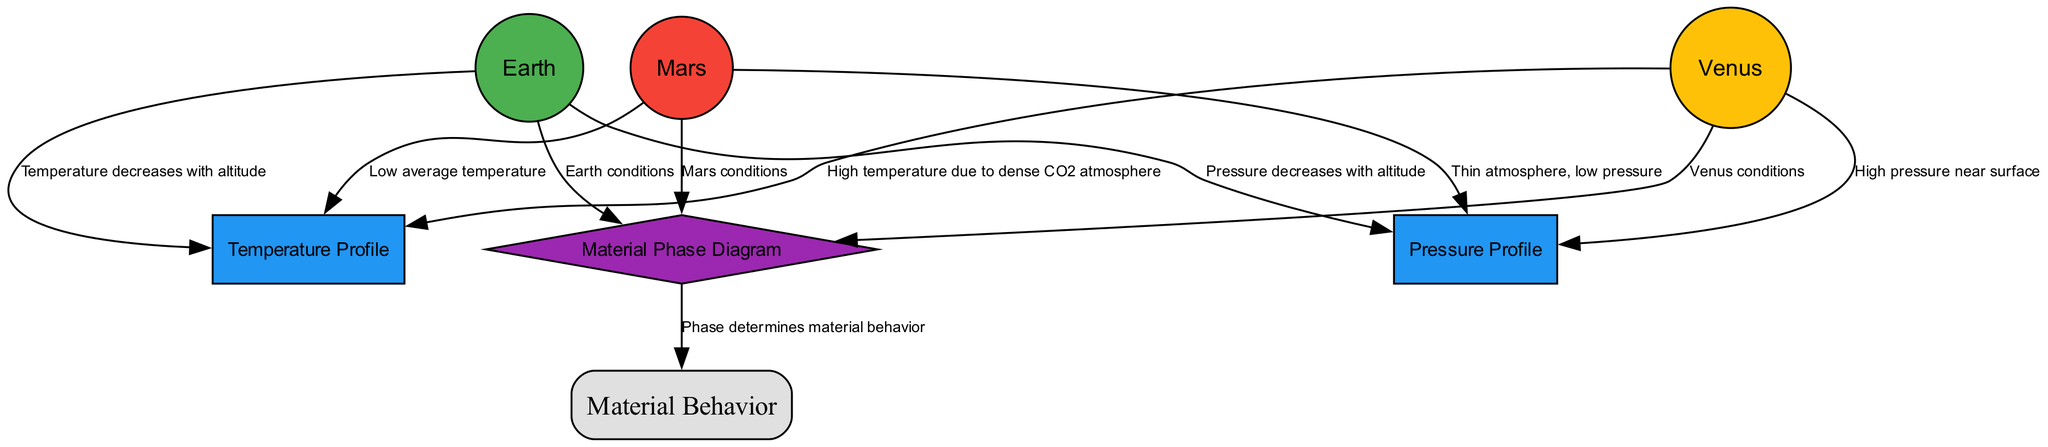What is the temperature on Venus? The diagram labels Venus with the description "Extreme conditions: 467°C", providing specific temperature data for Venus. Therefore, the temperature on Venus is directly mentioned in the diagram.
Answer: 467°C How many planets are represented in the diagram? The nodes section lists three planets: Earth, Venus, and Mars. The count of nodes that represent planets gives us the total number of planets in the diagram.
Answer: 3 What causes the high pressure on Venus? The diagram indicates that Venus has "High pressure near surface" due to its "dense CO2 atmosphere," suggesting the atmosphere's composition contributes to the pressure levels experienced on Venus.
Answer: Dense CO2 atmosphere What happens to temperature with altitude on Earth? The edge from Earth to TempProfile states "Temperature decreases with altitude", indicating that temperature reduces as one ascends in the atmosphere on Earth based on the relationships depicted in the diagram.
Answer: Decreases Which planet has the lowest atmospheric pressure? The description for Mars states "Thin atmosphere, low pressure," which is compared to the other planets depicted. Thus, Mars's atmospheric conditions show that it has the lowest pressure among the three.
Answer: Mars What does the Material Phase Diagram show? The PhaseDiagram node states, "Shows the phase of material (solid, liquid, gas) under various conditions." This defines the phase behavior of materials as indicated in the diagram.
Answer: Material phases How many edges are connected to the planet Venus? By analyzing the edges connected to Venus, there are two edges: one leading to TempProfile and the other to PressProfile. Counting these edges indicates the total connections Venus has within the diagram.
Answer: 2 What relationship does the Phase Diagram have with Material Behavior? The edge labeled "Phase determines material behavior" connects the PhaseDiagram node to the MaterialBehavior node. This establishes a direct relationship between the material's phase and its behavior under varying planetary conditions.
Answer: Phase determines behavior What is the average temperature condition of Mars? The description for Mars states "Cold conditions: -60°C", which provides the average temperature data specifically for Mars in the diagram.
Answer: -60°C 